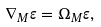Convert formula to latex. <formula><loc_0><loc_0><loc_500><loc_500>\nabla _ { M } \varepsilon = \Omega _ { M } \varepsilon ,</formula> 